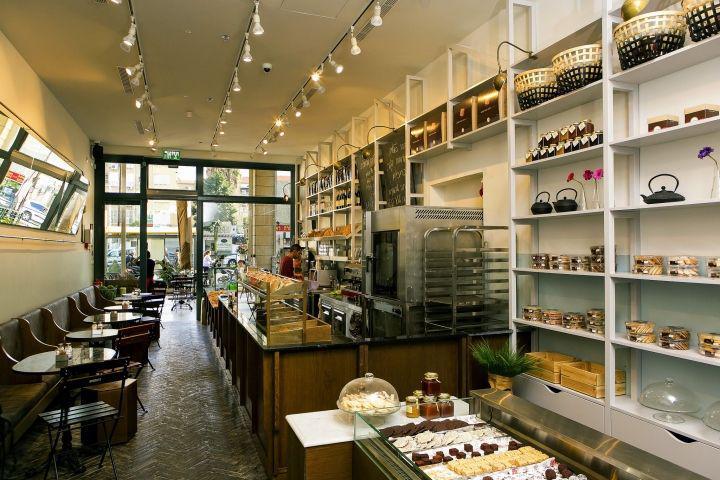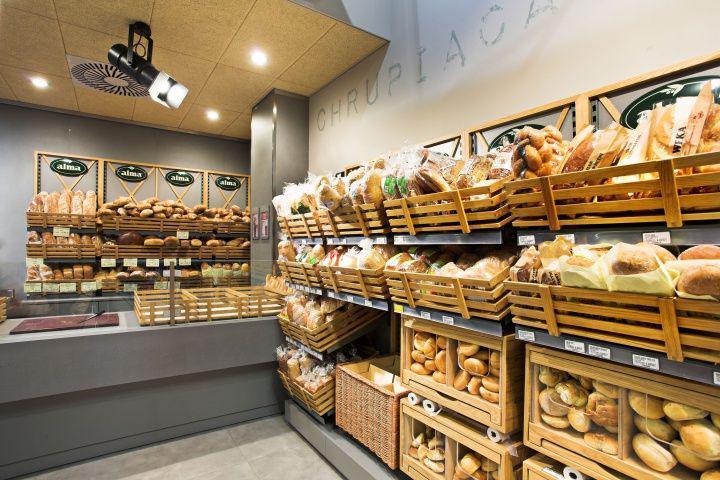The first image is the image on the left, the second image is the image on the right. Considering the images on both sides, is "the bakery sign is on the wall" valid? Answer yes or no. No. 